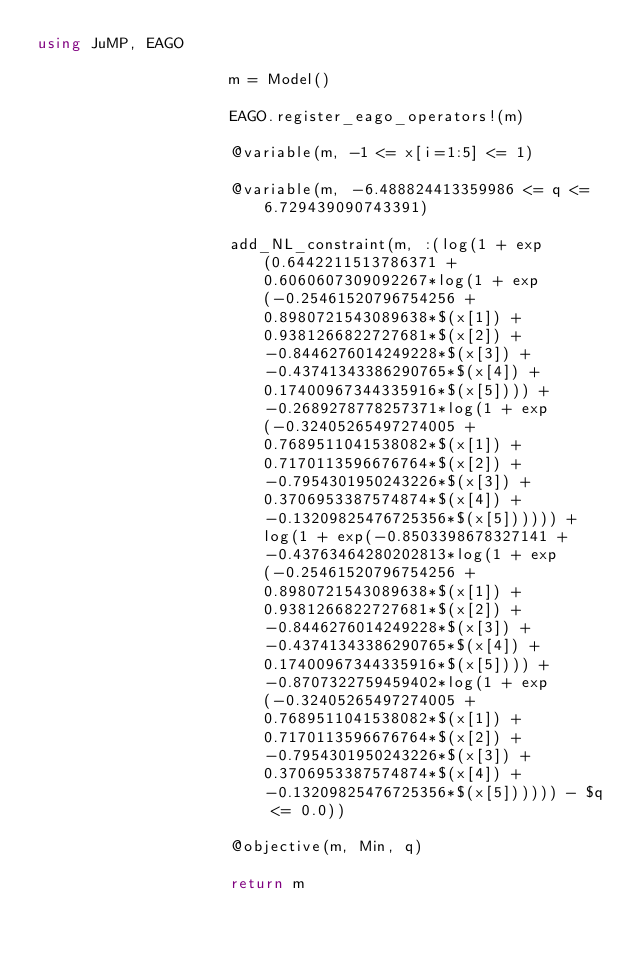Convert code to text. <code><loc_0><loc_0><loc_500><loc_500><_Julia_>using JuMP, EAGO

                     m = Model()

                     EAGO.register_eago_operators!(m)

                     @variable(m, -1 <= x[i=1:5] <= 1)

                     @variable(m, -6.488824413359986 <= q <= 6.729439090743391)

                     add_NL_constraint(m, :(log(1 + exp(0.6442211513786371 + 0.6060607309092267*log(1 + exp(-0.25461520796754256 + 0.8980721543089638*$(x[1]) + 0.9381266822727681*$(x[2]) + -0.8446276014249228*$(x[3]) + -0.43741343386290765*$(x[4]) + 0.17400967344335916*$(x[5]))) + -0.2689278778257371*log(1 + exp(-0.32405265497274005 + 0.7689511041538082*$(x[1]) + 0.7170113596676764*$(x[2]) + -0.7954301950243226*$(x[3]) + 0.3706953387574874*$(x[4]) + -0.13209825476725356*$(x[5]))))) + log(1 + exp(-0.8503398678327141 + -0.43763464280202813*log(1 + exp(-0.25461520796754256 + 0.8980721543089638*$(x[1]) + 0.9381266822727681*$(x[2]) + -0.8446276014249228*$(x[3]) + -0.43741343386290765*$(x[4]) + 0.17400967344335916*$(x[5]))) + -0.8707322759459402*log(1 + exp(-0.32405265497274005 + 0.7689511041538082*$(x[1]) + 0.7170113596676764*$(x[2]) + -0.7954301950243226*$(x[3]) + 0.3706953387574874*$(x[4]) + -0.13209825476725356*$(x[5]))))) - $q <= 0.0))

                     @objective(m, Min, q)

                     return m

                    </code> 